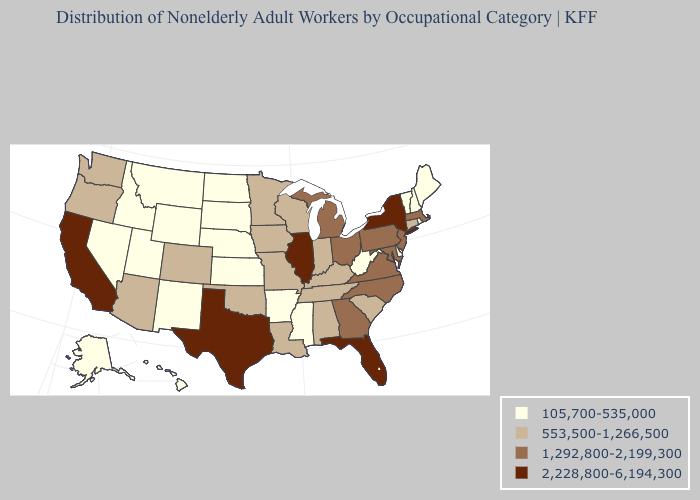Does Maryland have a lower value than New York?
Keep it brief. Yes. What is the highest value in the USA?
Quick response, please. 2,228,800-6,194,300. What is the highest value in the USA?
Give a very brief answer. 2,228,800-6,194,300. Name the states that have a value in the range 105,700-535,000?
Be succinct. Alaska, Arkansas, Delaware, Hawaii, Idaho, Kansas, Maine, Mississippi, Montana, Nebraska, Nevada, New Hampshire, New Mexico, North Dakota, Rhode Island, South Dakota, Utah, Vermont, West Virginia, Wyoming. Among the states that border South Carolina , which have the lowest value?
Be succinct. Georgia, North Carolina. Does Colorado have the highest value in the West?
Short answer required. No. Among the states that border Kentucky , does Indiana have the highest value?
Concise answer only. No. What is the value of Kansas?
Short answer required. 105,700-535,000. Among the states that border Utah , which have the lowest value?
Give a very brief answer. Idaho, Nevada, New Mexico, Wyoming. Name the states that have a value in the range 2,228,800-6,194,300?
Give a very brief answer. California, Florida, Illinois, New York, Texas. Does the first symbol in the legend represent the smallest category?
Give a very brief answer. Yes. What is the value of Connecticut?
Short answer required. 553,500-1,266,500. Name the states that have a value in the range 553,500-1,266,500?
Answer briefly. Alabama, Arizona, Colorado, Connecticut, Indiana, Iowa, Kentucky, Louisiana, Minnesota, Missouri, Oklahoma, Oregon, South Carolina, Tennessee, Washington, Wisconsin. Name the states that have a value in the range 2,228,800-6,194,300?
Answer briefly. California, Florida, Illinois, New York, Texas. Name the states that have a value in the range 553,500-1,266,500?
Write a very short answer. Alabama, Arizona, Colorado, Connecticut, Indiana, Iowa, Kentucky, Louisiana, Minnesota, Missouri, Oklahoma, Oregon, South Carolina, Tennessee, Washington, Wisconsin. 